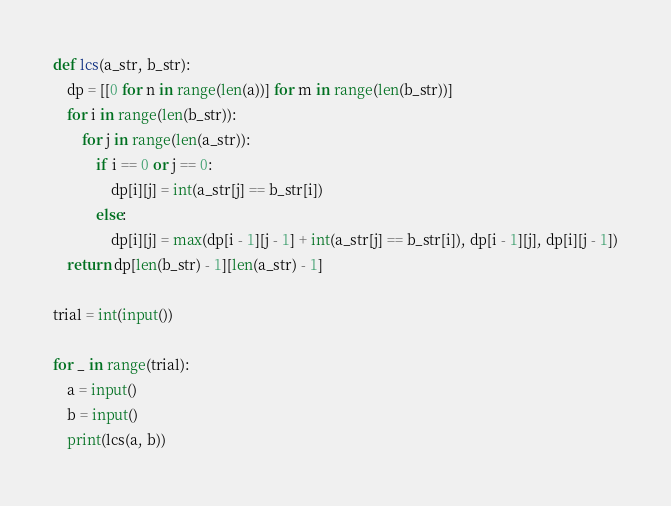<code> <loc_0><loc_0><loc_500><loc_500><_Python_>def lcs(a_str, b_str):
    dp = [[0 for n in range(len(a))] for m in range(len(b_str))]
    for i in range(len(b_str)):
        for j in range(len(a_str)):
            if i == 0 or j == 0:
                dp[i][j] = int(a_str[j] == b_str[i])
            else:
                dp[i][j] = max(dp[i - 1][j - 1] + int(a_str[j] == b_str[i]), dp[i - 1][j], dp[i][j - 1])
    return dp[len(b_str) - 1][len(a_str) - 1]

trial = int(input())

for _ in range(trial):
    a = input()
    b = input()
    print(lcs(a, b))


</code> 